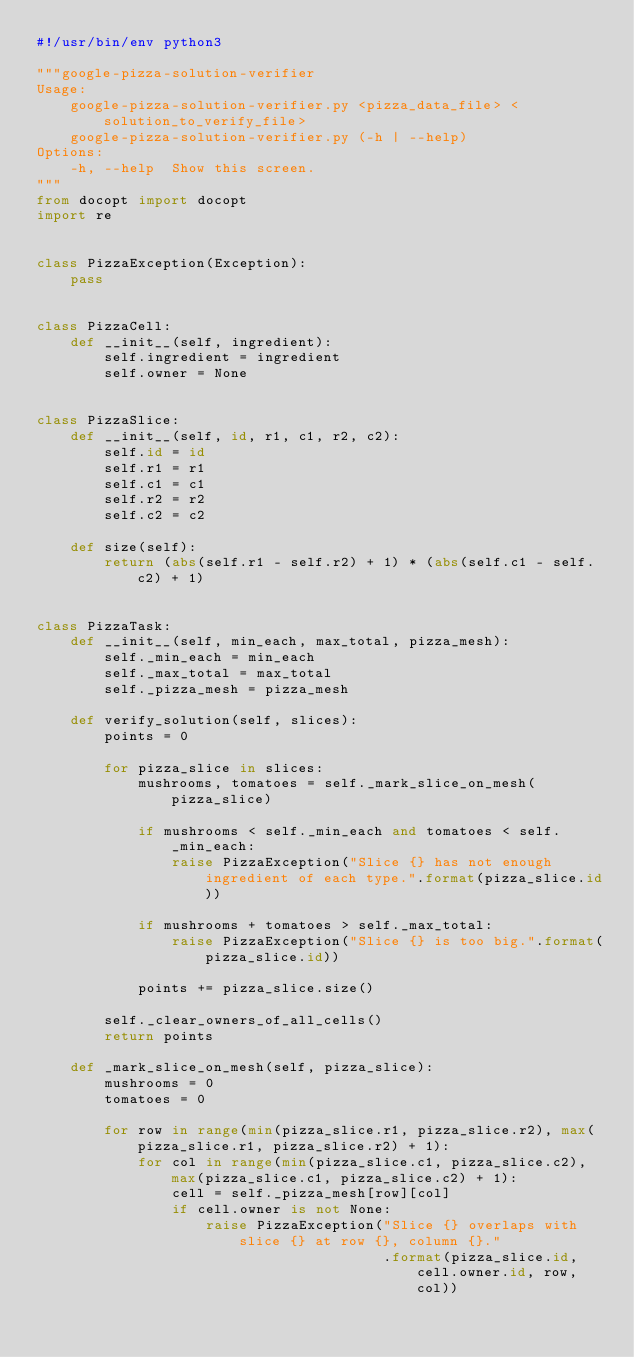<code> <loc_0><loc_0><loc_500><loc_500><_Python_>#!/usr/bin/env python3

"""google-pizza-solution-verifier
Usage:
    google-pizza-solution-verifier.py <pizza_data_file> <solution_to_verify_file>
    google-pizza-solution-verifier.py (-h | --help)
Options:
    -h, --help  Show this screen.
"""
from docopt import docopt
import re


class PizzaException(Exception):
    pass


class PizzaCell:
    def __init__(self, ingredient):
        self.ingredient = ingredient
        self.owner = None


class PizzaSlice:
    def __init__(self, id, r1, c1, r2, c2):
        self.id = id
        self.r1 = r1
        self.c1 = c1
        self.r2 = r2
        self.c2 = c2

    def size(self):
        return (abs(self.r1 - self.r2) + 1) * (abs(self.c1 - self.c2) + 1)


class PizzaTask:
    def __init__(self, min_each, max_total, pizza_mesh):
        self._min_each = min_each
        self._max_total = max_total
        self._pizza_mesh = pizza_mesh

    def verify_solution(self, slices):
        points = 0

        for pizza_slice in slices:
            mushrooms, tomatoes = self._mark_slice_on_mesh(pizza_slice)

            if mushrooms < self._min_each and tomatoes < self._min_each:
                raise PizzaException("Slice {} has not enough ingredient of each type.".format(pizza_slice.id))

            if mushrooms + tomatoes > self._max_total:
                raise PizzaException("Slice {} is too big.".format(pizza_slice.id))

            points += pizza_slice.size()

        self._clear_owners_of_all_cells()
        return points

    def _mark_slice_on_mesh(self, pizza_slice):
        mushrooms = 0
        tomatoes = 0

        for row in range(min(pizza_slice.r1, pizza_slice.r2), max(pizza_slice.r1, pizza_slice.r2) + 1):
            for col in range(min(pizza_slice.c1, pizza_slice.c2), max(pizza_slice.c1, pizza_slice.c2) + 1):
                cell = self._pizza_mesh[row][col]
                if cell.owner is not None:
                    raise PizzaException("Slice {} overlaps with slice {} at row {}, column {}."
                                         .format(pizza_slice.id, cell.owner.id, row, col))
</code> 